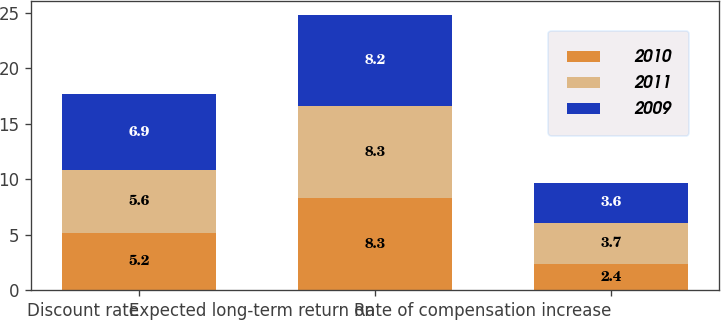Convert chart to OTSL. <chart><loc_0><loc_0><loc_500><loc_500><stacked_bar_chart><ecel><fcel>Discount rate<fcel>Expected long-term return on<fcel>Rate of compensation increase<nl><fcel>2010<fcel>5.2<fcel>8.3<fcel>2.4<nl><fcel>2011<fcel>5.6<fcel>8.3<fcel>3.7<nl><fcel>2009<fcel>6.9<fcel>8.2<fcel>3.6<nl></chart> 